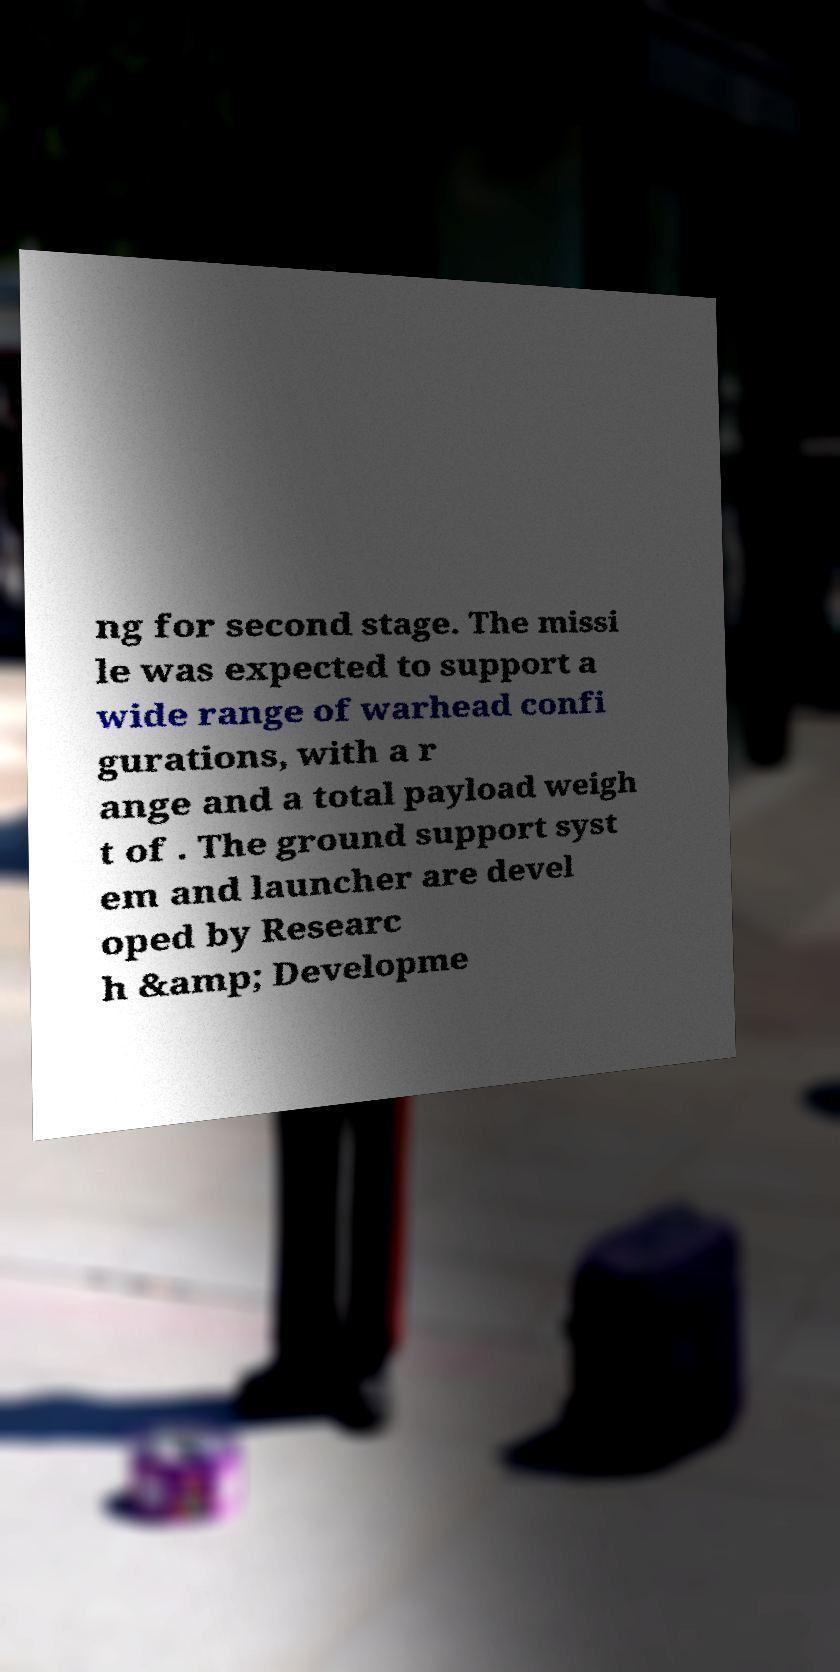Could you assist in decoding the text presented in this image and type it out clearly? ng for second stage. The missi le was expected to support a wide range of warhead confi gurations, with a r ange and a total payload weigh t of . The ground support syst em and launcher are devel oped by Researc h &amp; Developme 